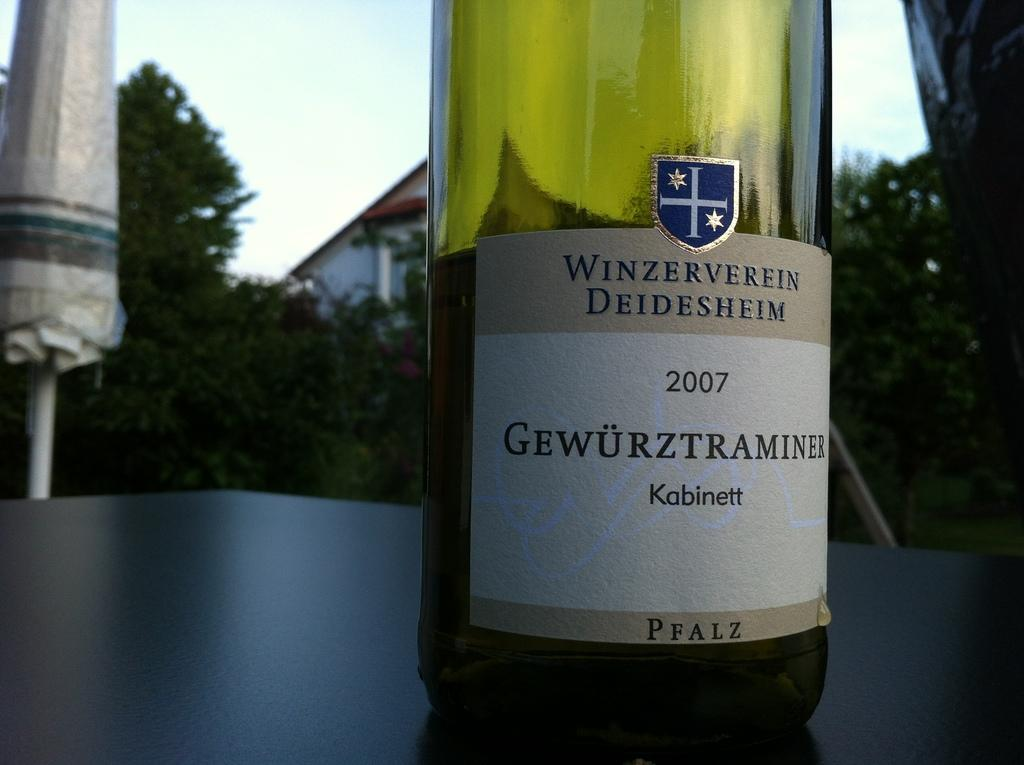Provide a one-sentence caption for the provided image. a bottle of Winzerverein Deidesheim Kabinett 2007 wine. 